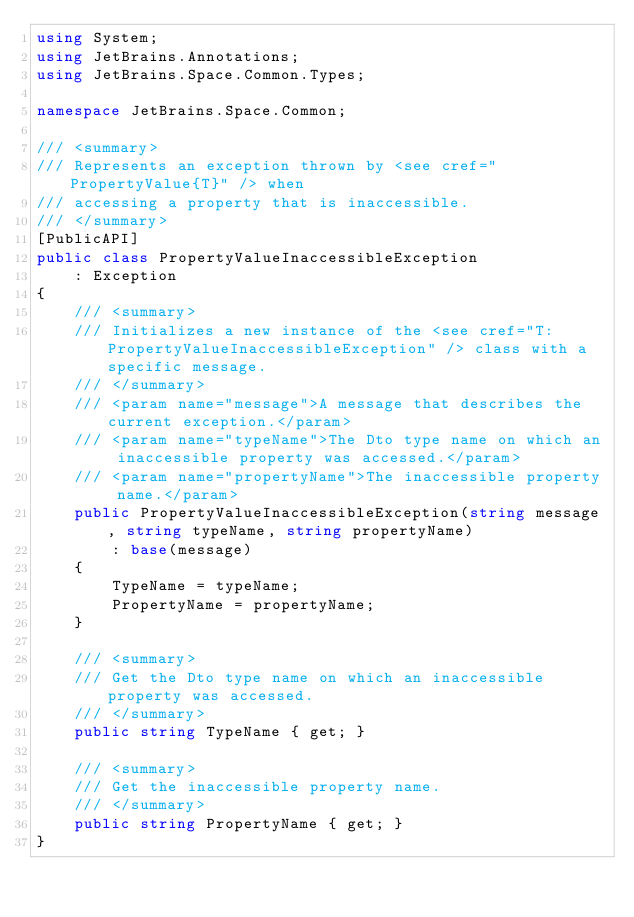Convert code to text. <code><loc_0><loc_0><loc_500><loc_500><_C#_>using System;
using JetBrains.Annotations;
using JetBrains.Space.Common.Types;

namespace JetBrains.Space.Common;

/// <summary>
/// Represents an exception thrown by <see cref="PropertyValue{T}" /> when
/// accessing a property that is inaccessible.
/// </summary>
[PublicAPI]
public class PropertyValueInaccessibleException 
    : Exception
{
    /// <summary>
    /// Initializes a new instance of the <see cref="T:PropertyValueInaccessibleException" /> class with a specific message.
    /// </summary>
    /// <param name="message">A message that describes the current exception.</param>
    /// <param name="typeName">The Dto type name on which an inaccessible property was accessed.</param>
    /// <param name="propertyName">The inaccessible property name.</param>
    public PropertyValueInaccessibleException(string message, string typeName, string propertyName) 
        : base(message)
    {
        TypeName = typeName;
        PropertyName = propertyName;
    }
        
    /// <summary>
    /// Get the Dto type name on which an inaccessible property was accessed.
    /// </summary>
    public string TypeName { get; }

    /// <summary>
    /// Get the inaccessible property name.
    /// </summary>
    public string PropertyName { get; }
}</code> 